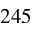<formula> <loc_0><loc_0><loc_500><loc_500>2 4 5</formula> 